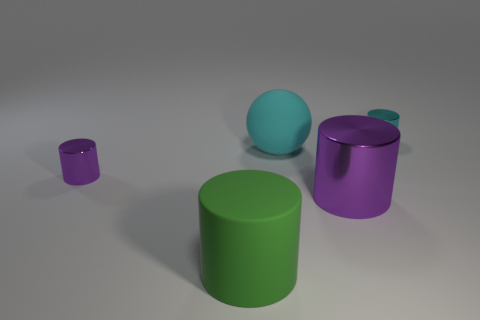There is a big sphere; does it have the same color as the tiny metal cylinder to the right of the rubber cylinder?
Give a very brief answer. Yes. What is the shape of the large cyan rubber object?
Offer a terse response. Sphere. Does the small metallic object on the left side of the sphere have the same shape as the cyan matte thing?
Ensure brevity in your answer.  No. Is the number of purple metal cylinders that are on the left side of the large purple metallic cylinder greater than the number of large green cylinders behind the big green thing?
Give a very brief answer. Yes. How many other objects are the same size as the cyan shiny cylinder?
Provide a short and direct response. 1. There is a large green rubber object; does it have the same shape as the rubber thing to the right of the matte cylinder?
Your answer should be very brief. No. How many rubber things are tiny purple objects or small red balls?
Ensure brevity in your answer.  0. Is there a small metal thing of the same color as the ball?
Offer a very short reply. Yes. Are any purple shiny objects visible?
Your response must be concise. Yes. Do the large shiny object and the large green matte thing have the same shape?
Provide a short and direct response. Yes. 